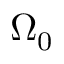<formula> <loc_0><loc_0><loc_500><loc_500>\Omega _ { 0 }</formula> 